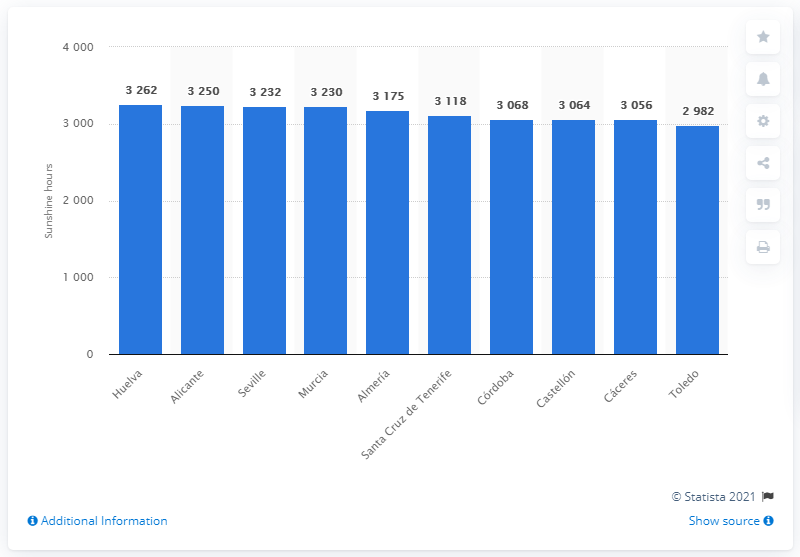Draw attention to some important aspects in this diagram. Huelva was the city in Spain that had the most sunny days in 2018, with over 3,200 hours of sunshine. 